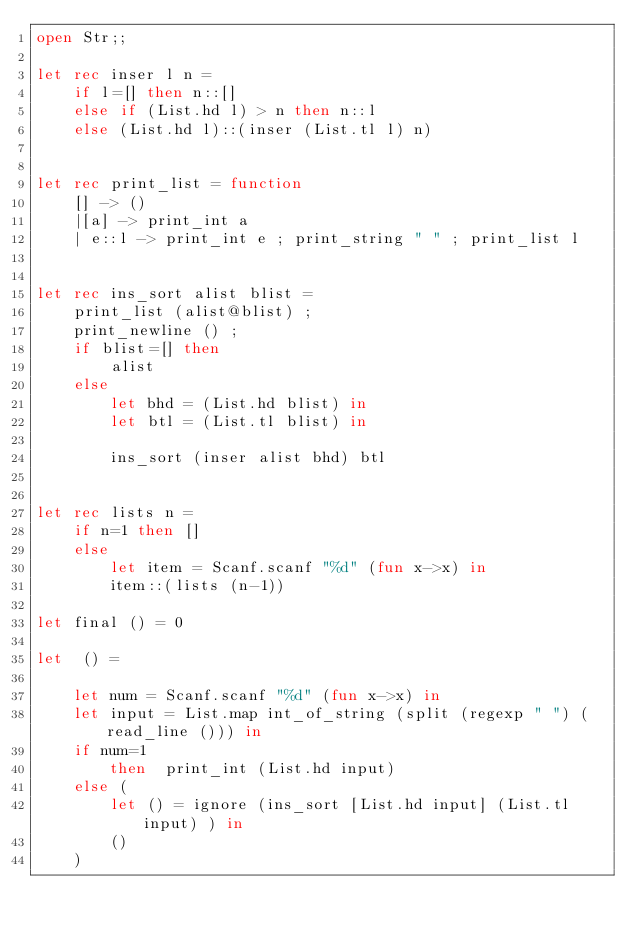<code> <loc_0><loc_0><loc_500><loc_500><_OCaml_>open Str;;

let rec inser l n =
    if l=[] then n::[]
    else if (List.hd l) > n then n::l
    else (List.hd l)::(inser (List.tl l) n)


let rec print_list = function 
    [] -> ()
    |[a] -> print_int a
    | e::l -> print_int e ; print_string " " ; print_list l


let rec ins_sort alist blist =
    print_list (alist@blist) ;
    print_newline () ;
    if blist=[] then
        alist
    else
        let bhd = (List.hd blist) in
        let btl = (List.tl blist) in

        ins_sort (inser alist bhd) btl


let rec lists n =
    if n=1 then []
    else
        let item = Scanf.scanf "%d" (fun x->x) in
        item::(lists (n-1))

let final () = 0 

let  () =

    let num = Scanf.scanf "%d" (fun x->x) in
    let input = List.map int_of_string (split (regexp " ") (read_line ())) in
    if num=1 
        then  print_int (List.hd input) 
    else (
        let () = ignore (ins_sort [List.hd input] (List.tl input) ) in
        ()
    )</code> 